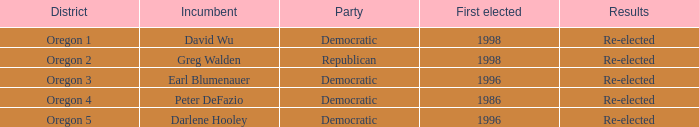Which democratic officeholder was initially elected in 1998? David Wu. 